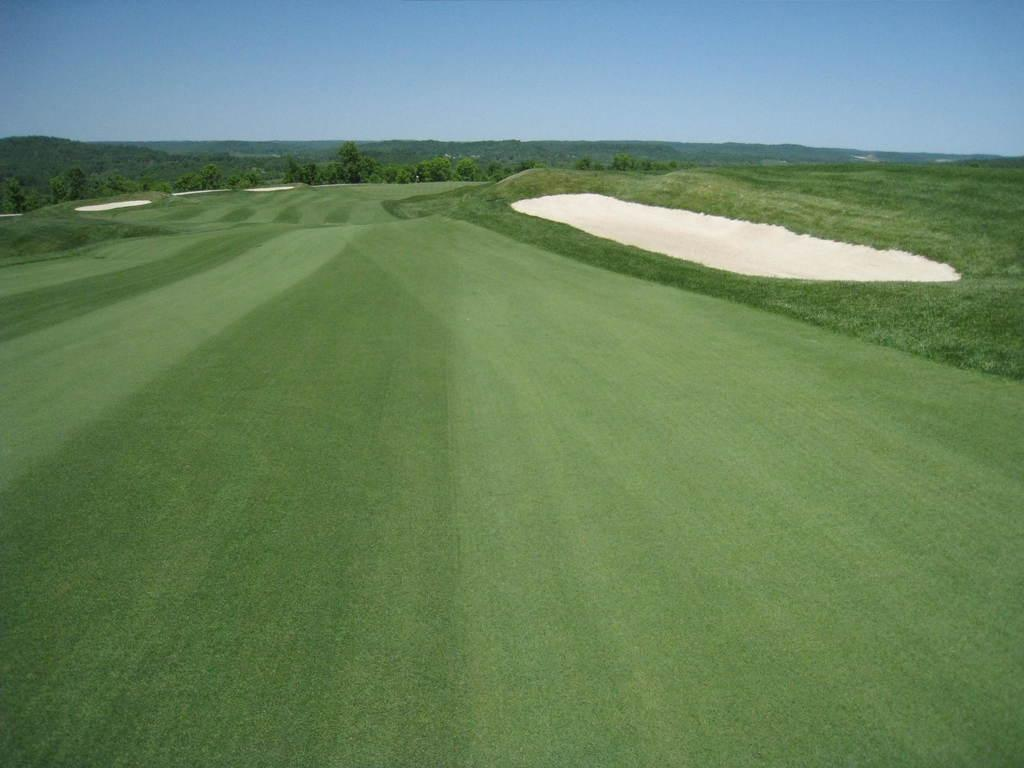What type of surface is visible in the image? There is a grass surface in the image. What is located on the grass surface? There is a cream-colored surface on the grass. What can be seen in the background of the image? There are plants and the sky visible in the background of the image. What scent can be detected from the image? There is no information about a scent in the image, as it only shows a grass surface, a cream-colored surface, plants, and the sky. 